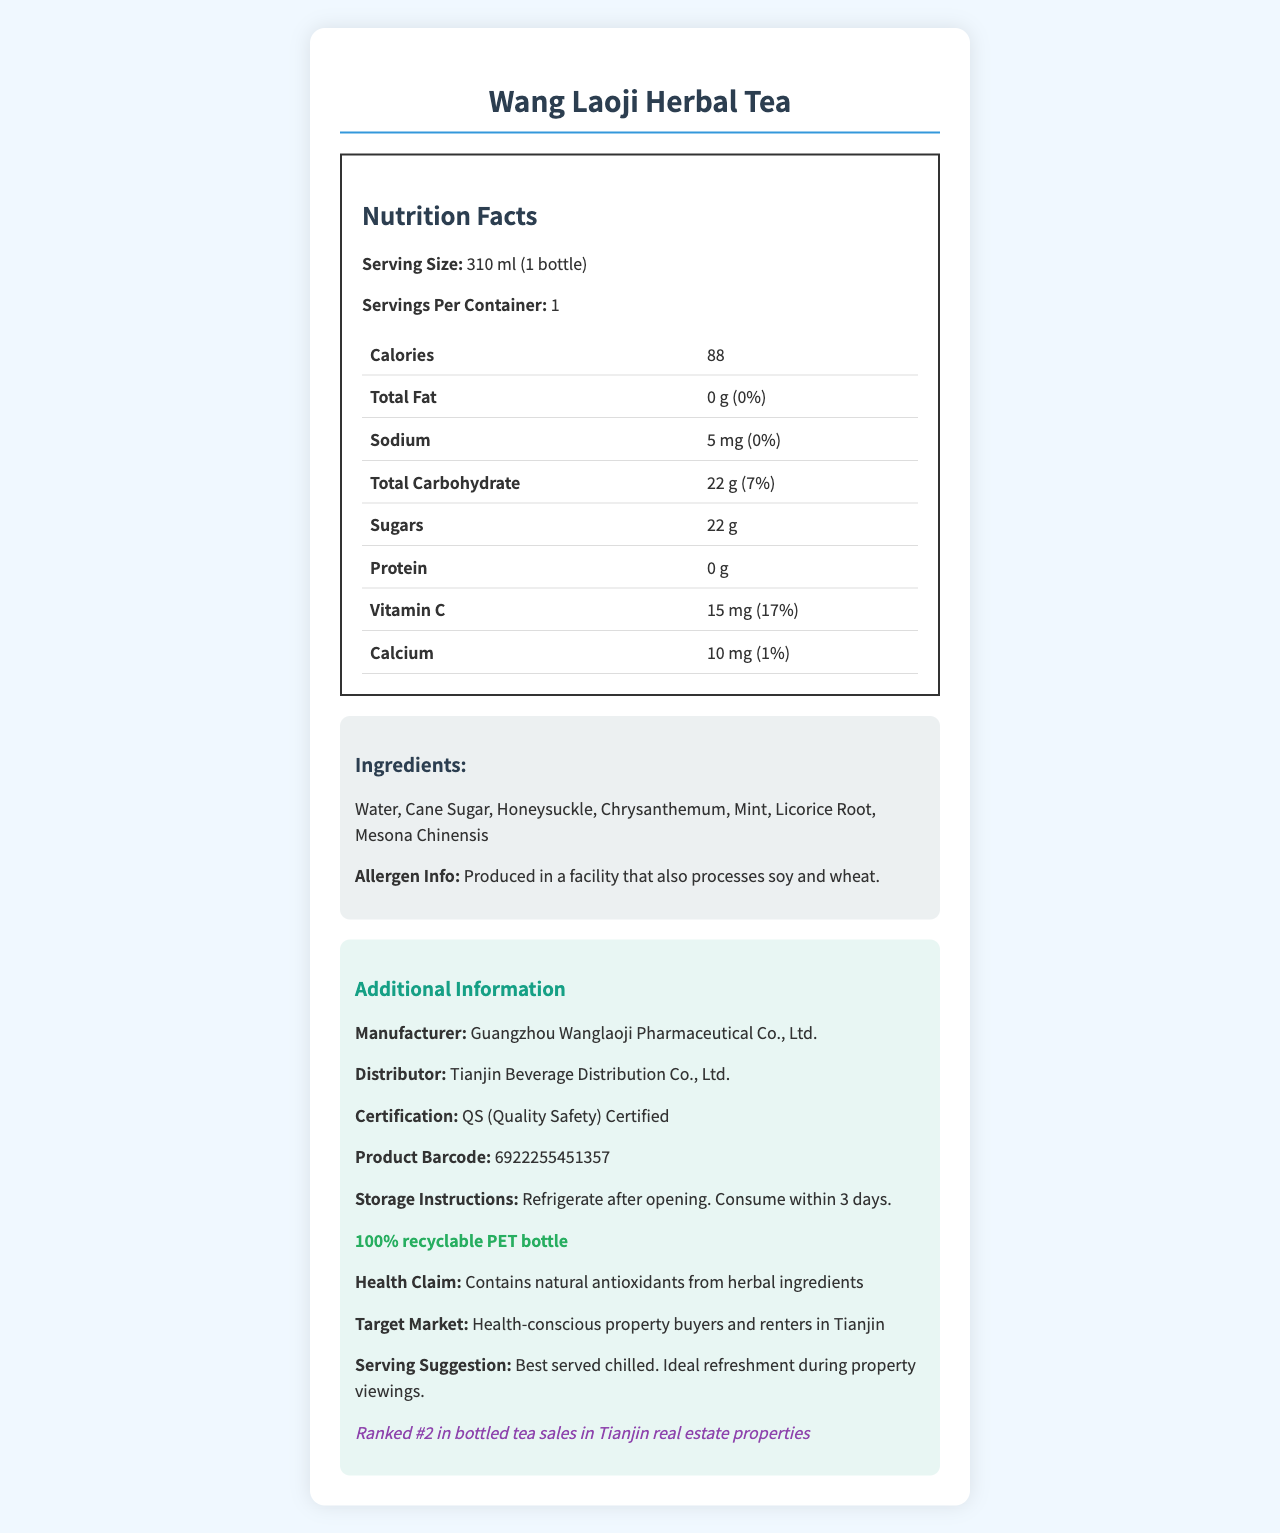what is the serving size of Wang Laoji Herbal Tea? The serving size is stated as "310 ml (1 bottle)" in the nutrition facts section.
Answer: 310 ml (1 bottle) how many calories are in one bottle of Wang Laoji Herbal Tea? The document lists the calories per serving as 88, and since there is 1 serving per container, a whole bottle contains 88 calories.
Answer: 88 calories what is the total carbohydrate content per serving? The total carbohydrate content is listed as "22 g" with a daily value percentage of "7%" in the nutrition facts.
Answer: 22 g (7%) is this product suitable for someone monitoring their sodium intake? The sodium content is listed as 5 mg, which is 0% of the daily value, making it very low in sodium.
Answer: Yes what are the three main ingredients of Wang Laoji Herbal Tea? The ingredients list starts with "Water, Cane Sugar, Honeysuckle."
Answer: Water, Cane Sugar, Honeysuckle which vitamins and minerals are included in this product, and in what amounts? The document lists Vitamin C content as 15 mg (17% daily value) and Calcium content as 10 mg (1% daily value).
Answer: Vitamin C - 15 mg (17%), Calcium - 10 mg (1%) how long should the product be consumed after opening? The storage instructions specify "Consume within 3 days" after opening.
Answer: Within 3 days where is the Wang Laoji Herbal Tea ranked in bottled tea sales within Tianjin real estate properties? The document states that it is "Ranked #2 in bottled tea sales in Tianjin real estate properties."
Answer: Ranked #2 which of the following ingredients are in Wang Laoji Herbal Tea? (a) Licorice Root (b) Ginseng (c) Green Tea The ingredients list includes "Licorice Root," but not Ginseng or Green Tea.
Answer: (a) Licorice Root who is the distributor of this product? (i) Guangzhou Wanglaoji Pharmaceutical Co., Ltd. (ii) Tianjin Beverage Distribution Co., Ltd. (iii) Beijing Herbal Drinks Co., Ltd. The distributor is listed as "Tianjin Beverage Distribution Co., Ltd."
Answer: (ii) Tianjin Beverage Distribution Co., Ltd. does the product contain natural antioxidants? The health claim section states that it "Contains natural antioxidants from herbal ingredients."
Answer: Yes summarize the main details provided in the document about Wang Laoji Herbal Tea. This concise summary covers the key nutrients, ingredients, popularity, and packaging details of the product.
Answer: Wang Laoji Herbal Tea is a popular herbal tea beverage produced by Guangzhou Wanglaoji Pharmaceutical Co., Ltd. sold in a 310 ml bottle, containing 88 calories, 0g fat, 22g carbohydrates, and 5mg sodium per serving. It includes ingredients such as water, cane sugar, and honeysuckle. The product has vitamin C and calcium and is best served chilled. It’s particularly popular in Tianjin real estate properties, ranked #2 in sales. The product comes in a 100% recyclable PET bottle and claims to contain natural antioxidants. does this drink contain any protein? The nutrition facts section lists the protein content as "0 g," indicating the drink contains no protein.
Answer: No how does the eco-friendliness of the product’s packaging contribute to its appeal? The document mentions that the packaging is 100% recyclable PET, but does not provide specific details on consumer preferences regarding eco-friendliness.
Answer: Cannot be determined 